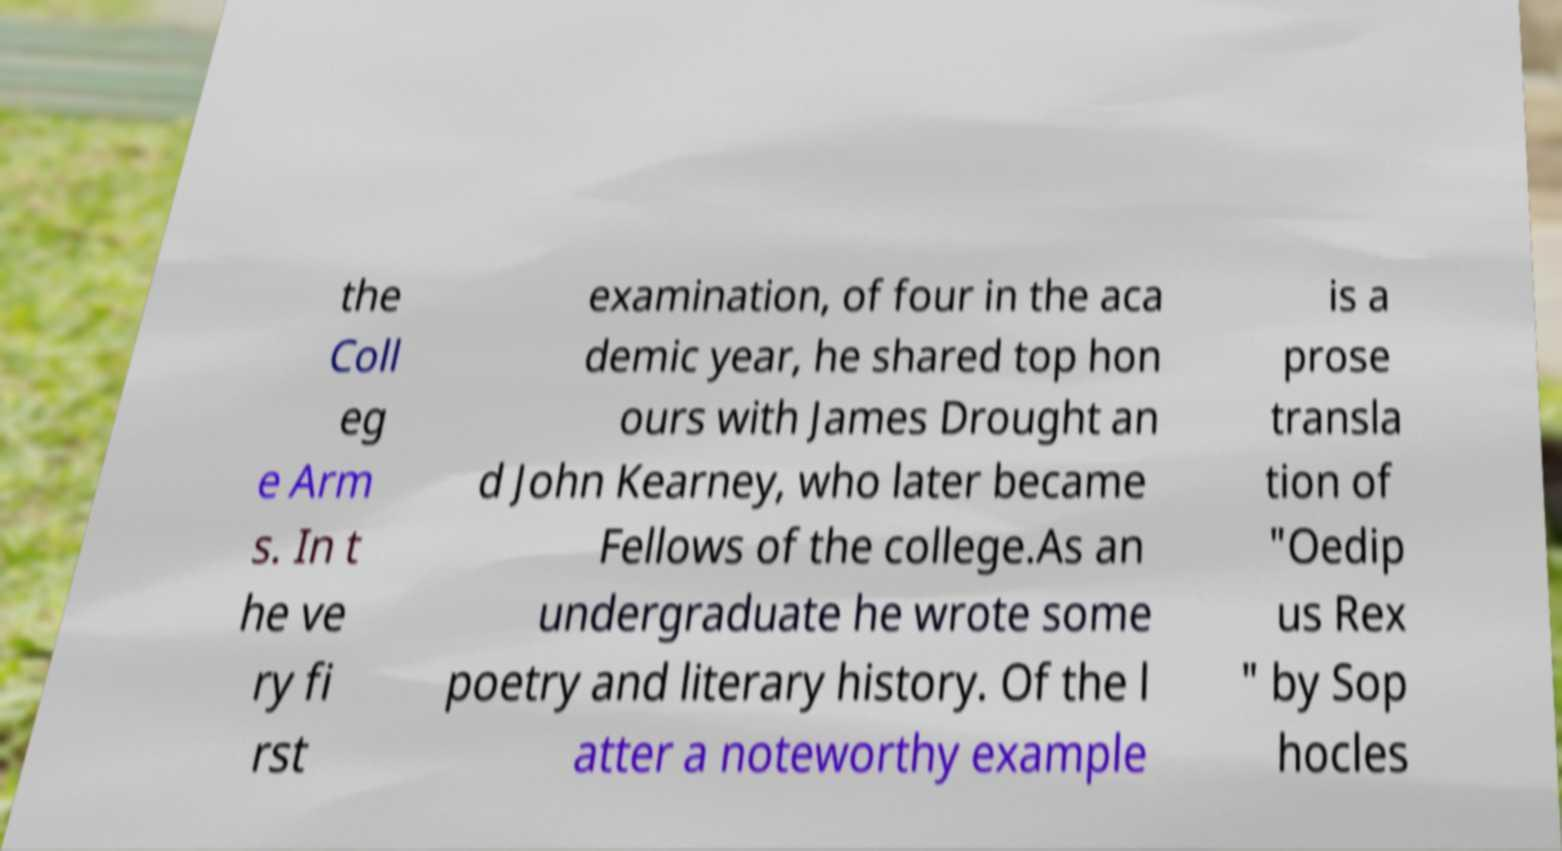Please read and relay the text visible in this image. What does it say? the Coll eg e Arm s. In t he ve ry fi rst examination, of four in the aca demic year, he shared top hon ours with James Drought an d John Kearney, who later became Fellows of the college.As an undergraduate he wrote some poetry and literary history. Of the l atter a noteworthy example is a prose transla tion of "Oedip us Rex " by Sop hocles 